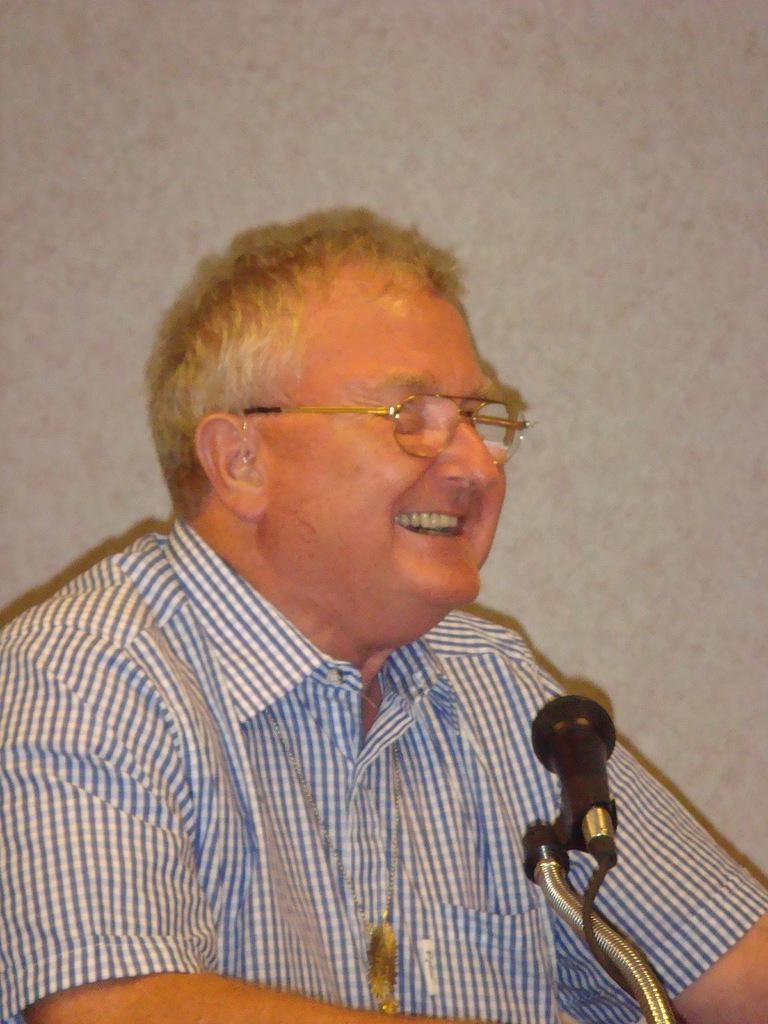In one or two sentences, can you explain what this image depicts? In this picture we can see a man with the spectacles and the man is smiling. In front of the man there is a microphone with a cable. Behind the man there is a wall. 